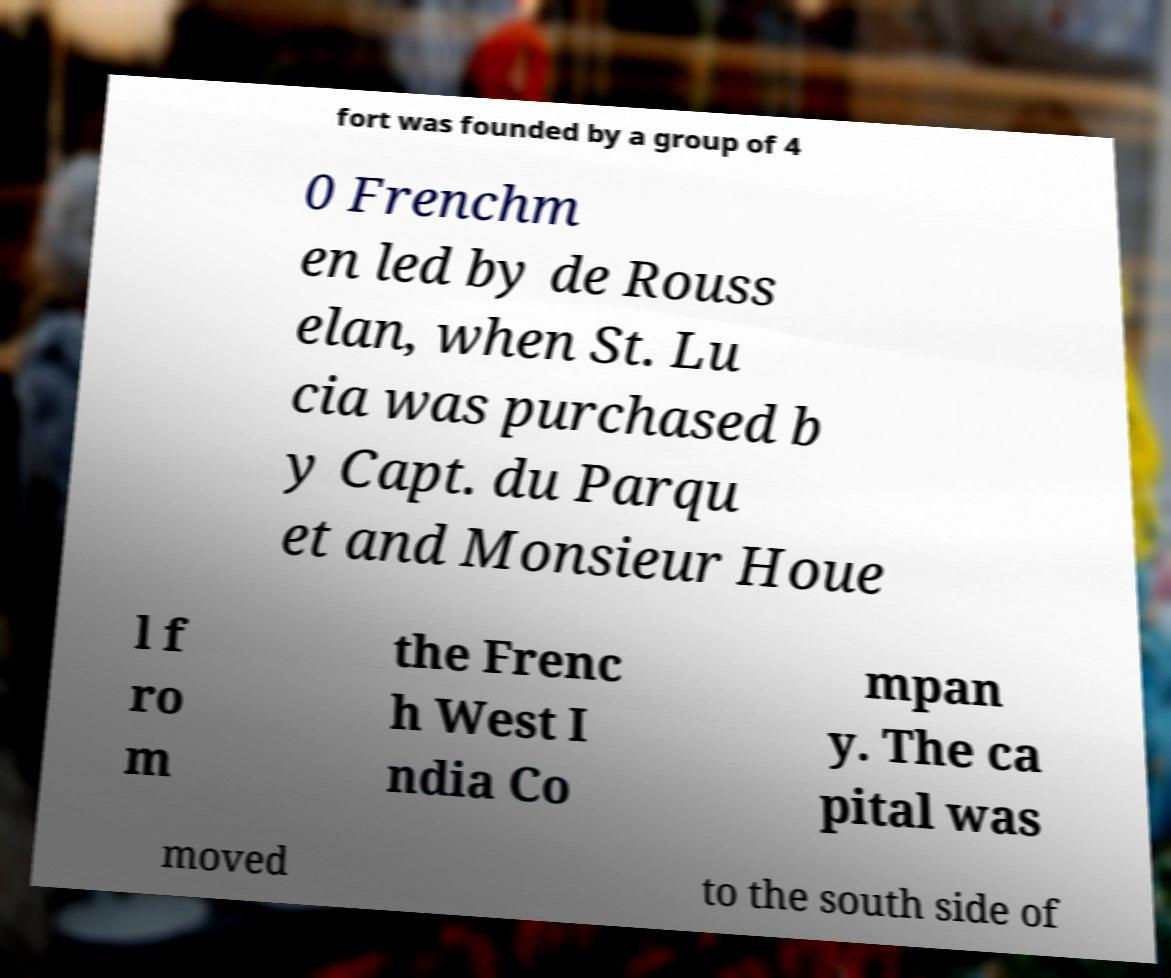Can you read and provide the text displayed in the image?This photo seems to have some interesting text. Can you extract and type it out for me? fort was founded by a group of 4 0 Frenchm en led by de Rouss elan, when St. Lu cia was purchased b y Capt. du Parqu et and Monsieur Houe l f ro m the Frenc h West I ndia Co mpan y. The ca pital was moved to the south side of 